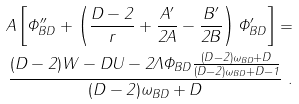<formula> <loc_0><loc_0><loc_500><loc_500>A \left [ \Phi _ { B D } ^ { \prime \prime } + \left ( \frac { D - 2 } { r } + \frac { A ^ { \prime } } { 2 A } - \frac { B ^ { \prime } } { 2 B } \right ) \Phi _ { B D } ^ { \prime } \right ] = \\ \frac { ( D - 2 ) W - D U - 2 \Lambda \Phi _ { B D } \frac { ( D - 2 ) \omega _ { B D } + D } { ( D - 2 ) \omega _ { B D } + D - 1 } } { ( D - 2 ) \omega _ { B D } + D } \ .</formula> 